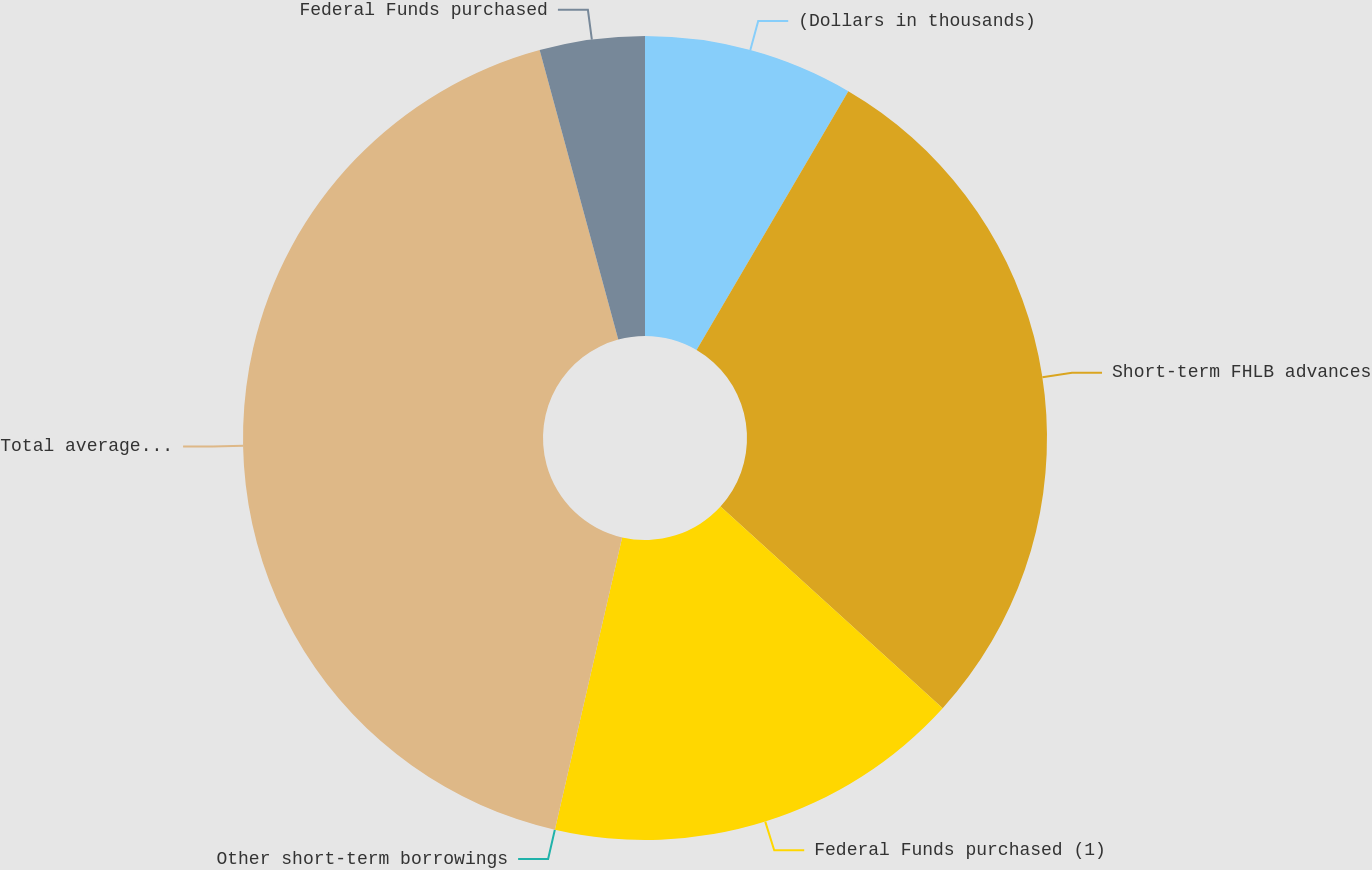<chart> <loc_0><loc_0><loc_500><loc_500><pie_chart><fcel>(Dollars in thousands)<fcel>Short-term FHLB advances<fcel>Federal Funds purchased (1)<fcel>Other short-term borrowings<fcel>Total average short-term<fcel>Federal Funds purchased<nl><fcel>8.44%<fcel>28.29%<fcel>16.87%<fcel>0.0%<fcel>42.18%<fcel>4.22%<nl></chart> 